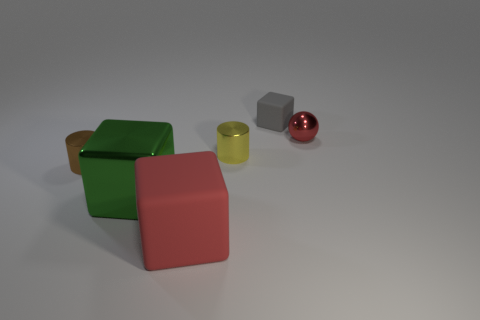What number of spheres are to the left of the cube that is left of the rubber block that is in front of the metal ball?
Offer a terse response. 0. Does the tiny shiny cylinder that is on the right side of the large green metal thing have the same color as the big rubber block?
Your response must be concise. No. What number of other things are the same shape as the red matte thing?
Your answer should be very brief. 2. How many other things are the same material as the tiny yellow cylinder?
Give a very brief answer. 3. There is a tiny thing on the right side of the cube behind the thing left of the big metal cube; what is its material?
Provide a short and direct response. Metal. Is the tiny block made of the same material as the large red thing?
Offer a terse response. Yes. How many cylinders are either red matte objects or yellow things?
Provide a succinct answer. 1. What color is the matte thing in front of the tiny red metal object?
Your answer should be very brief. Red. What number of shiny objects are purple things or brown things?
Make the answer very short. 1. There is a big thing that is on the left side of the rubber block left of the yellow metal cylinder; what is it made of?
Offer a very short reply. Metal. 